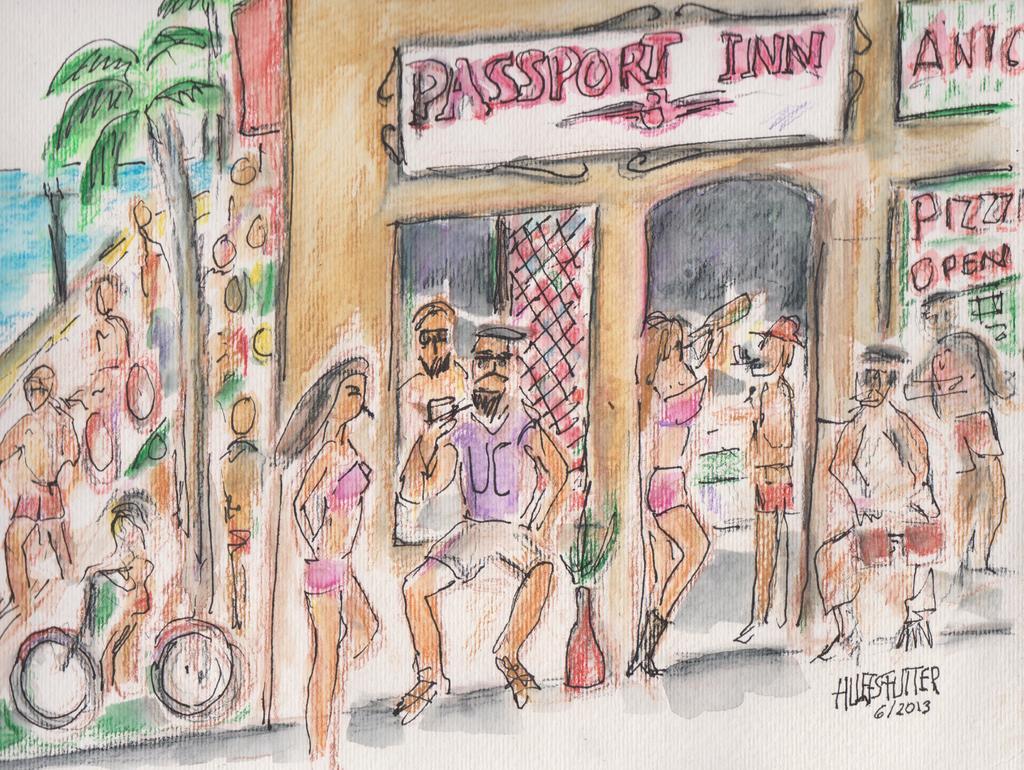Can you describe this image briefly? This is an animated image, where there are group of people standing , a building, tree, water, sky , bicycle and a signature on the image. 